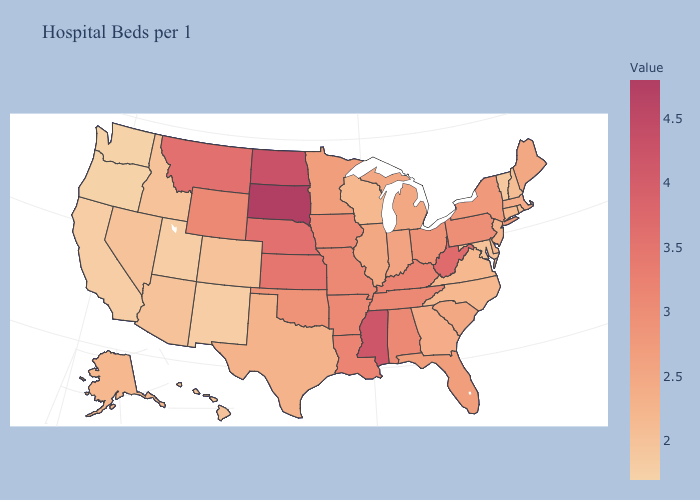Which states have the highest value in the USA?
Write a very short answer. South Dakota. Does South Carolina have the lowest value in the South?
Keep it brief. No. Does Mississippi have a lower value than South Dakota?
Concise answer only. Yes. Is the legend a continuous bar?
Quick response, please. Yes. Does Illinois have the highest value in the MidWest?
Give a very brief answer. No. 